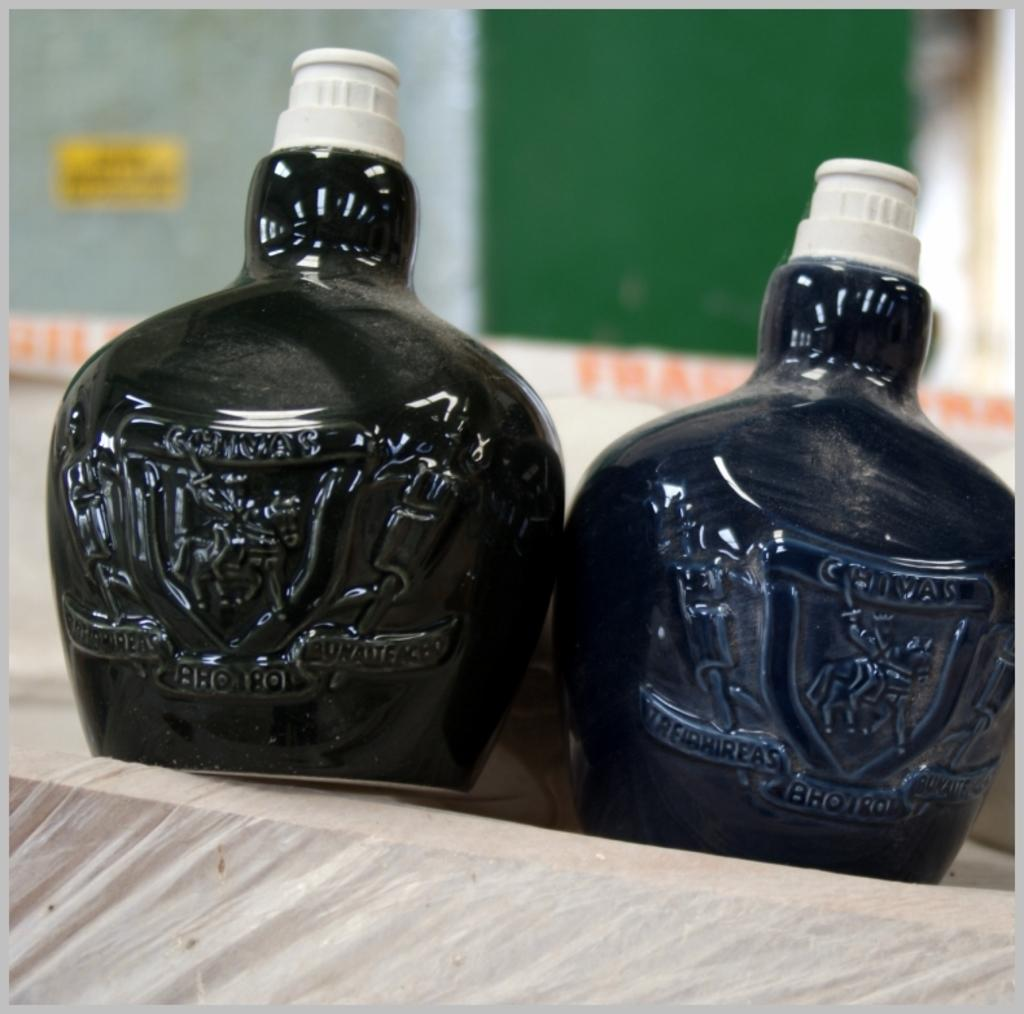Provide a one-sentence caption for the provided image. a small bottle with the name of chivas on it. 